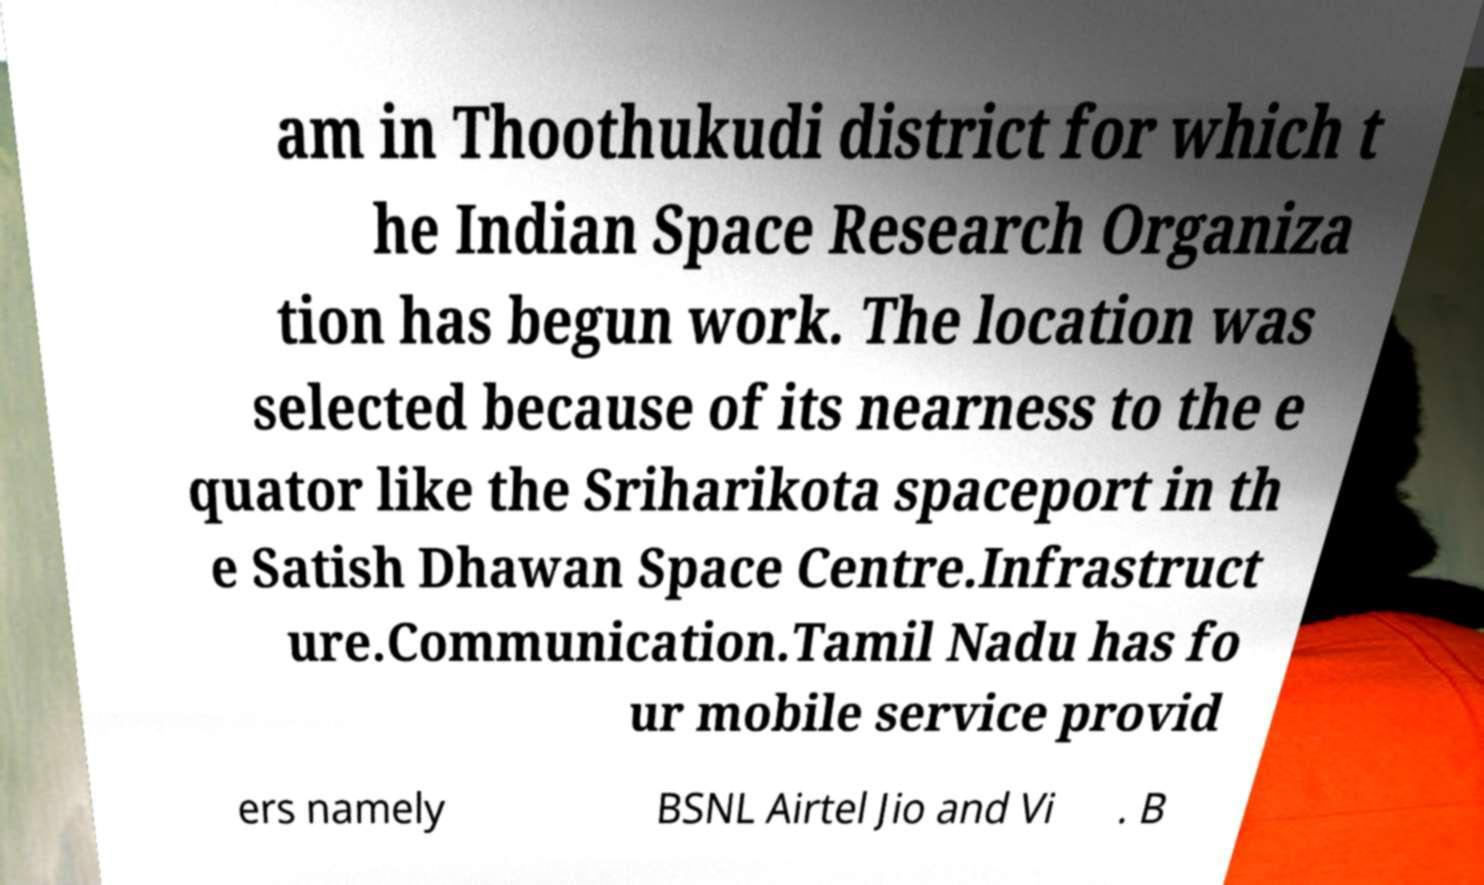There's text embedded in this image that I need extracted. Can you transcribe it verbatim? am in Thoothukudi district for which t he Indian Space Research Organiza tion has begun work. The location was selected because of its nearness to the e quator like the Sriharikota spaceport in th e Satish Dhawan Space Centre.Infrastruct ure.Communication.Tamil Nadu has fo ur mobile service provid ers namely BSNL Airtel Jio and Vi . B 